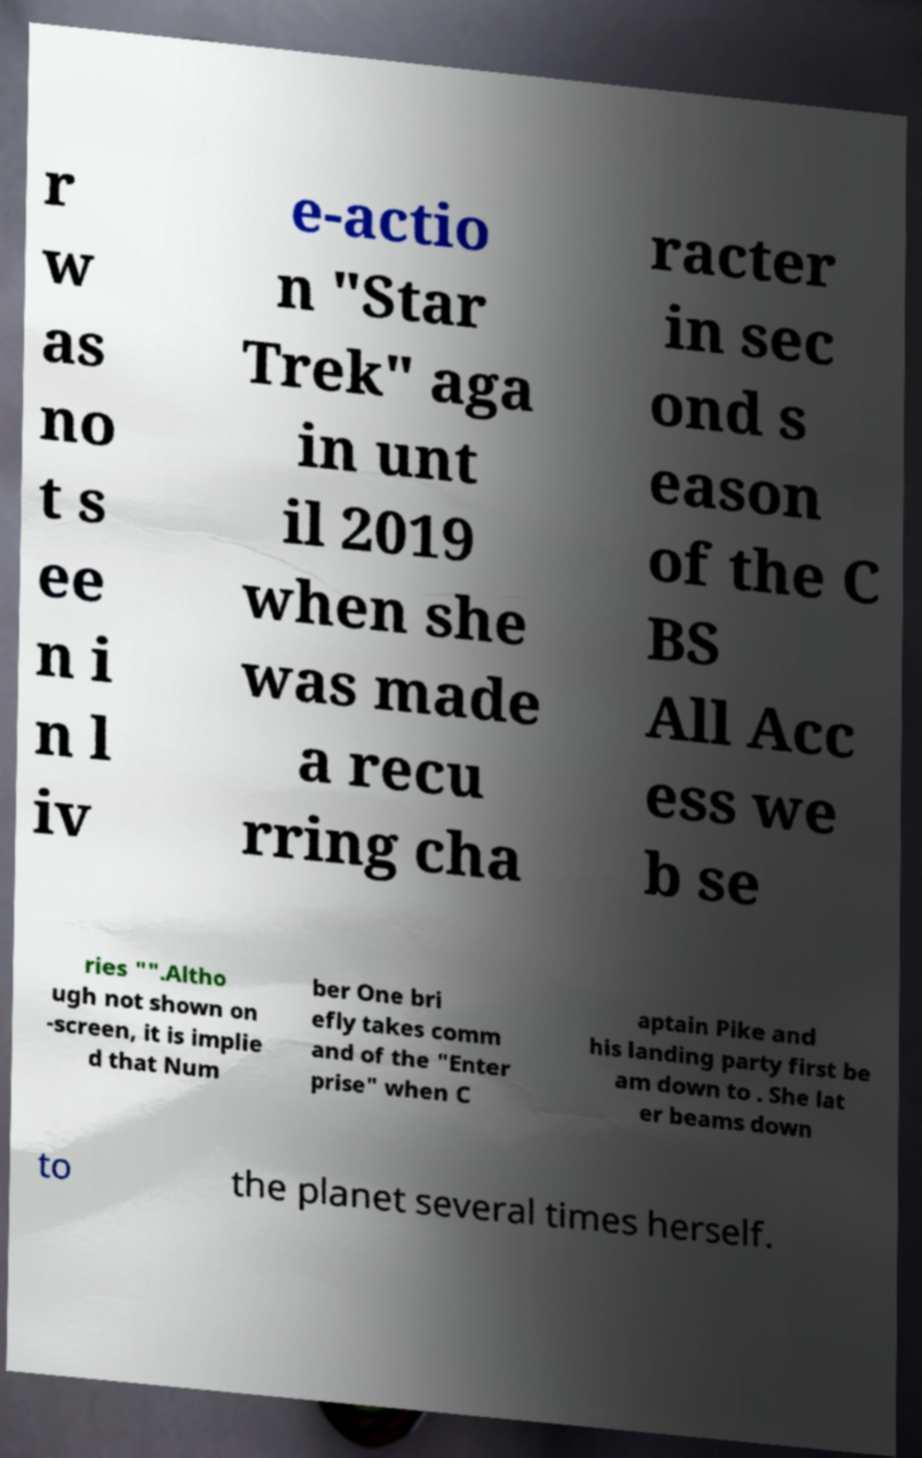Please identify and transcribe the text found in this image. r w as no t s ee n i n l iv e-actio n "Star Trek" aga in unt il 2019 when she was made a recu rring cha racter in sec ond s eason of the C BS All Acc ess we b se ries "".Altho ugh not shown on -screen, it is implie d that Num ber One bri efly takes comm and of the "Enter prise" when C aptain Pike and his landing party first be am down to . She lat er beams down to the planet several times herself. 